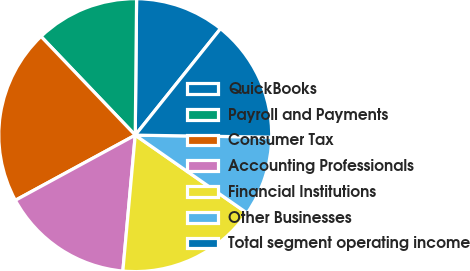Convert chart to OTSL. <chart><loc_0><loc_0><loc_500><loc_500><pie_chart><fcel>QuickBooks<fcel>Payroll and Payments<fcel>Consumer Tax<fcel>Accounting Professionals<fcel>Financial Institutions<fcel>Other Businesses<fcel>Total segment operating income<nl><fcel>10.59%<fcel>12.29%<fcel>20.79%<fcel>15.63%<fcel>16.76%<fcel>9.45%<fcel>14.49%<nl></chart> 